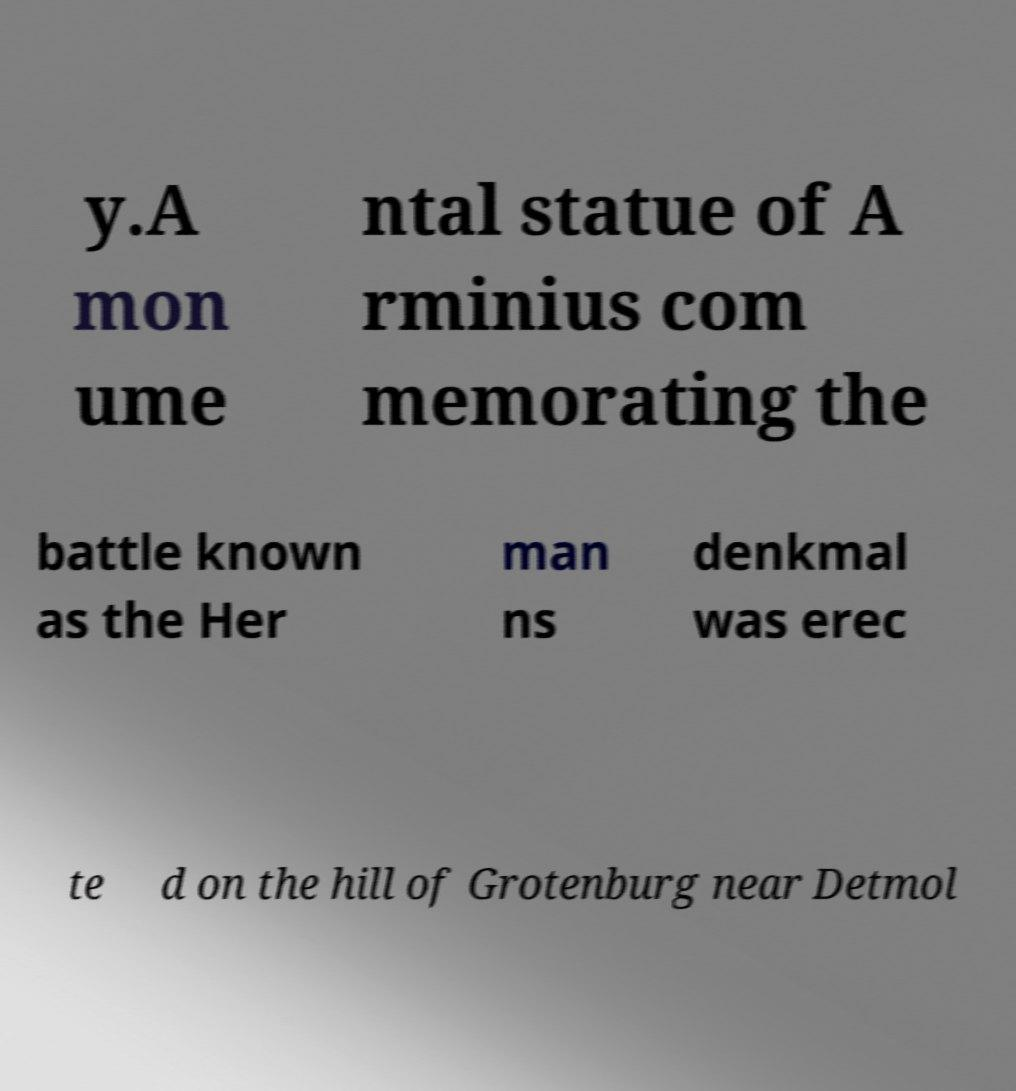Can you read and provide the text displayed in the image?This photo seems to have some interesting text. Can you extract and type it out for me? y.A mon ume ntal statue of A rminius com memorating the battle known as the Her man ns denkmal was erec te d on the hill of Grotenburg near Detmol 